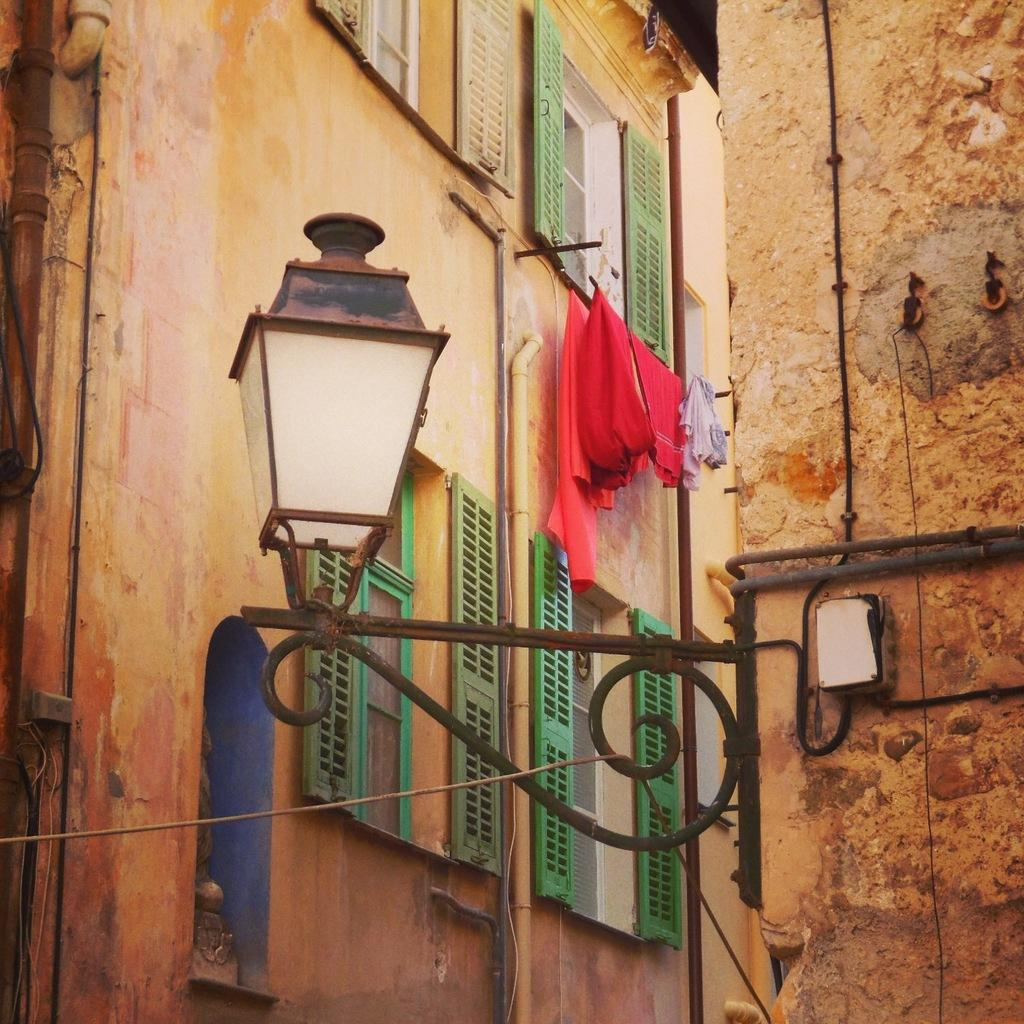What type of structures can be seen in the image? There are buildings in the image. What material is used for the rods in the image? Metal rods are present in the image. What is the source of illumination in the image? There is a light in the image. What can be seen hanging in the background of the image? Clothes are visible in the background. What type of plumbing feature is present on the wall in the background? Pipes are present on the wall in the background. What type of rice is being cooked in the image? There is no rice present in the image. What type of insurance policy is being discussed in the image? There is no discussion of insurance in the image. 